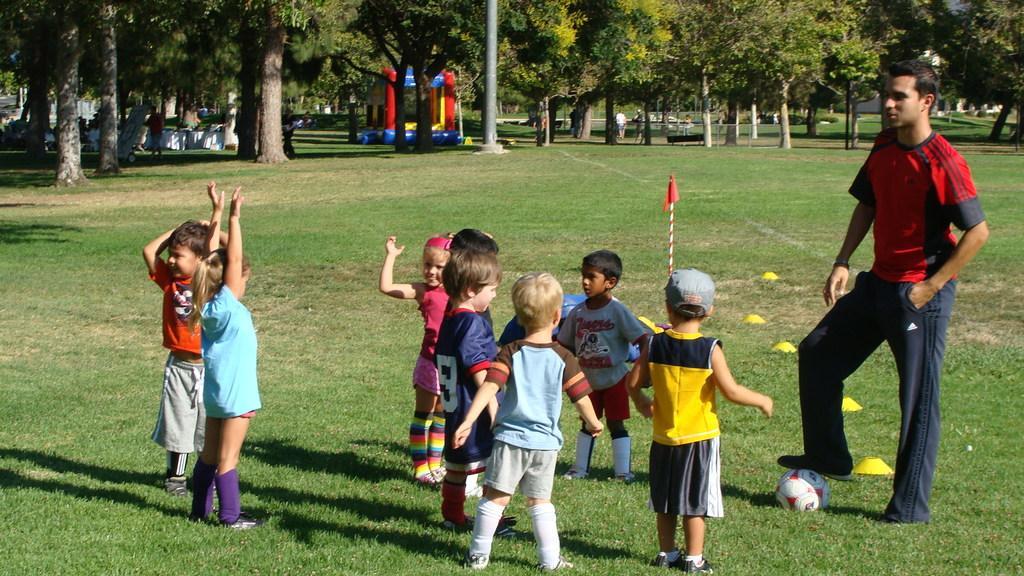How would you summarize this image in a sentence or two? Land is covered with grass. Here we can see a person, ball and children. Background there are trees, inflatable, people, bench and signboard. 